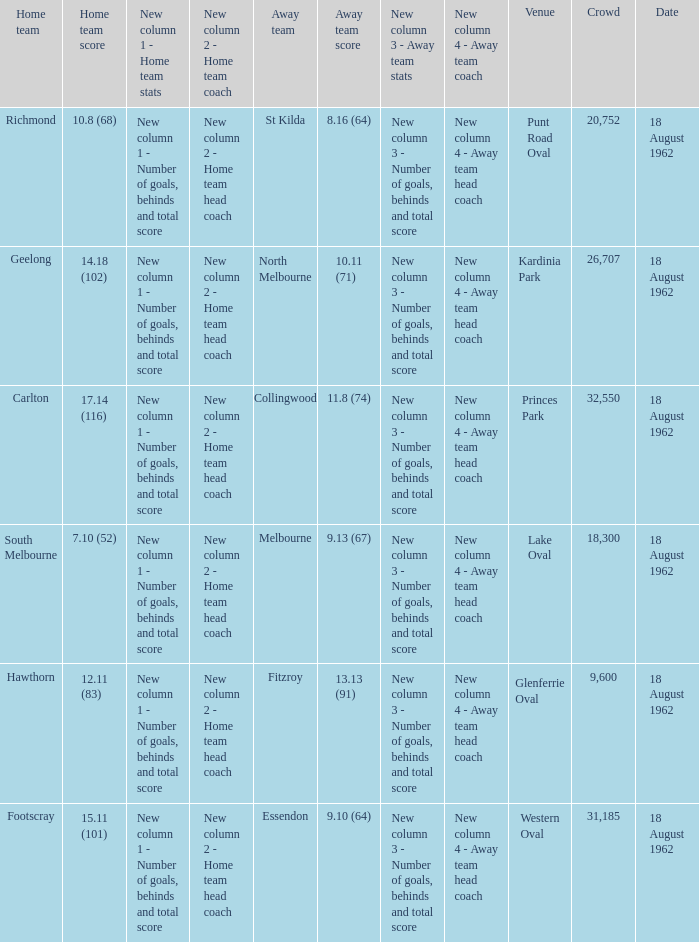At what venue where the home team scored 12.11 (83) was the crowd larger than 31,185? None. 